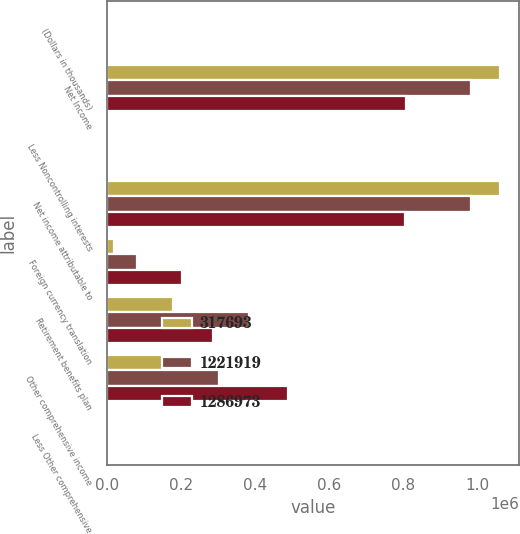Convert chart. <chart><loc_0><loc_0><loc_500><loc_500><stacked_bar_chart><ecel><fcel>(Dollars in thousands)<fcel>Net Income<fcel>Less Noncontrolling interests<fcel>Net income attributable to<fcel>Foreign currency translation<fcel>Retirement benefits plan<fcel>Other comprehensive income<fcel>Less Other comprehensive<nl><fcel>317693<fcel>2018<fcel>1.06132e+06<fcel>514<fcel>1.0608e+06<fcel>18575<fcel>179253<fcel>160678<fcel>440<nl><fcel>1.22192e+06<fcel>2017<fcel>983844<fcel>432<fcel>983412<fcel>80865<fcel>384784<fcel>303919<fcel>358<nl><fcel>1.28697e+06<fcel>2016<fcel>807216<fcel>376<fcel>806840<fcel>203299<fcel>286044<fcel>489343<fcel>196<nl></chart> 